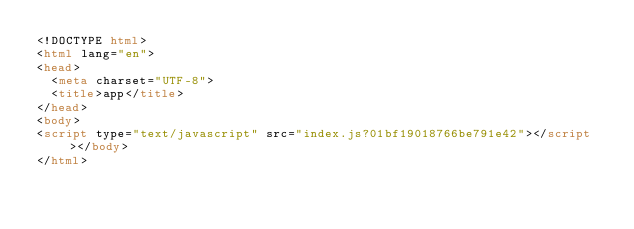<code> <loc_0><loc_0><loc_500><loc_500><_HTML_><!DOCTYPE html>
<html lang="en">
<head>
  <meta charset="UTF-8">
  <title>app</title>
</head>
<body>
<script type="text/javascript" src="index.js?01bf19018766be791e42"></script></body>
</html></code> 